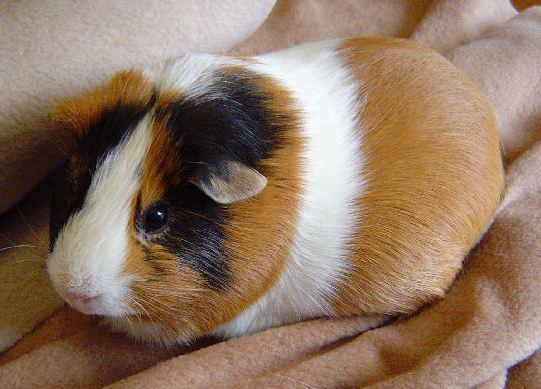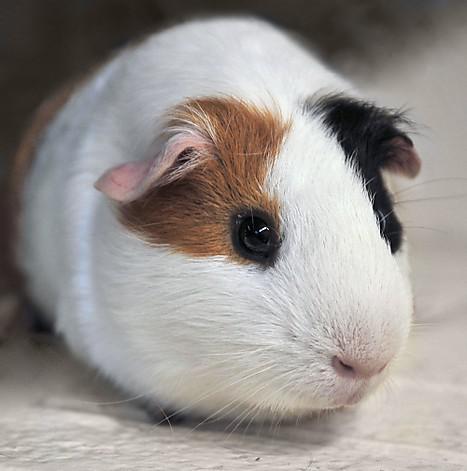The first image is the image on the left, the second image is the image on the right. Considering the images on both sides, is "There are two rodents" valid? Answer yes or no. Yes. 